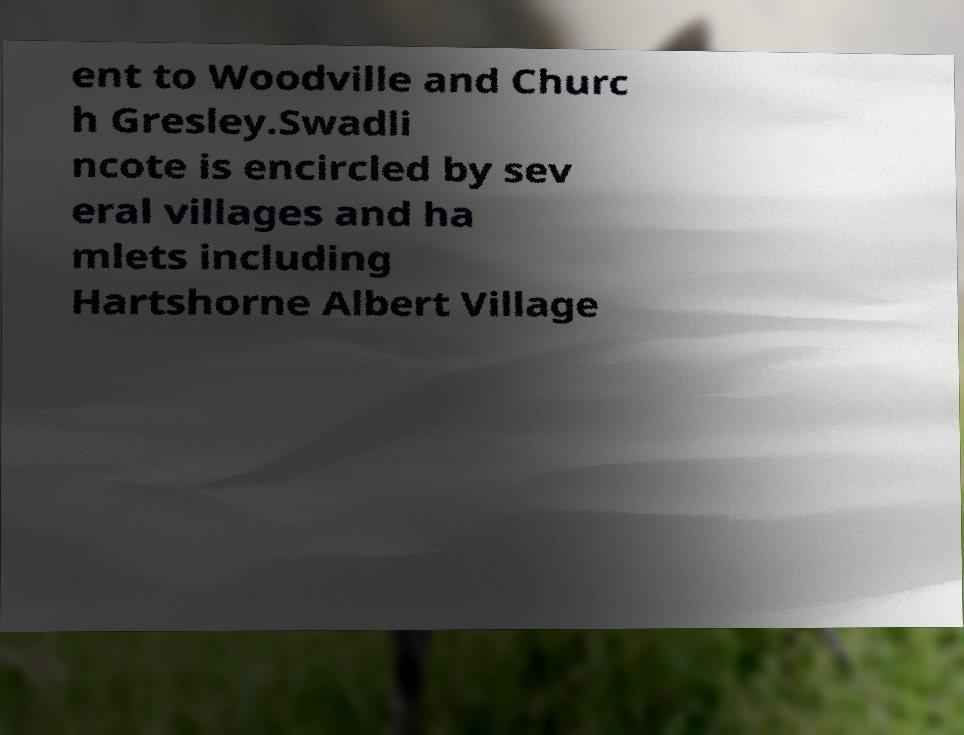Can you read and provide the text displayed in the image?This photo seems to have some interesting text. Can you extract and type it out for me? ent to Woodville and Churc h Gresley.Swadli ncote is encircled by sev eral villages and ha mlets including Hartshorne Albert Village 